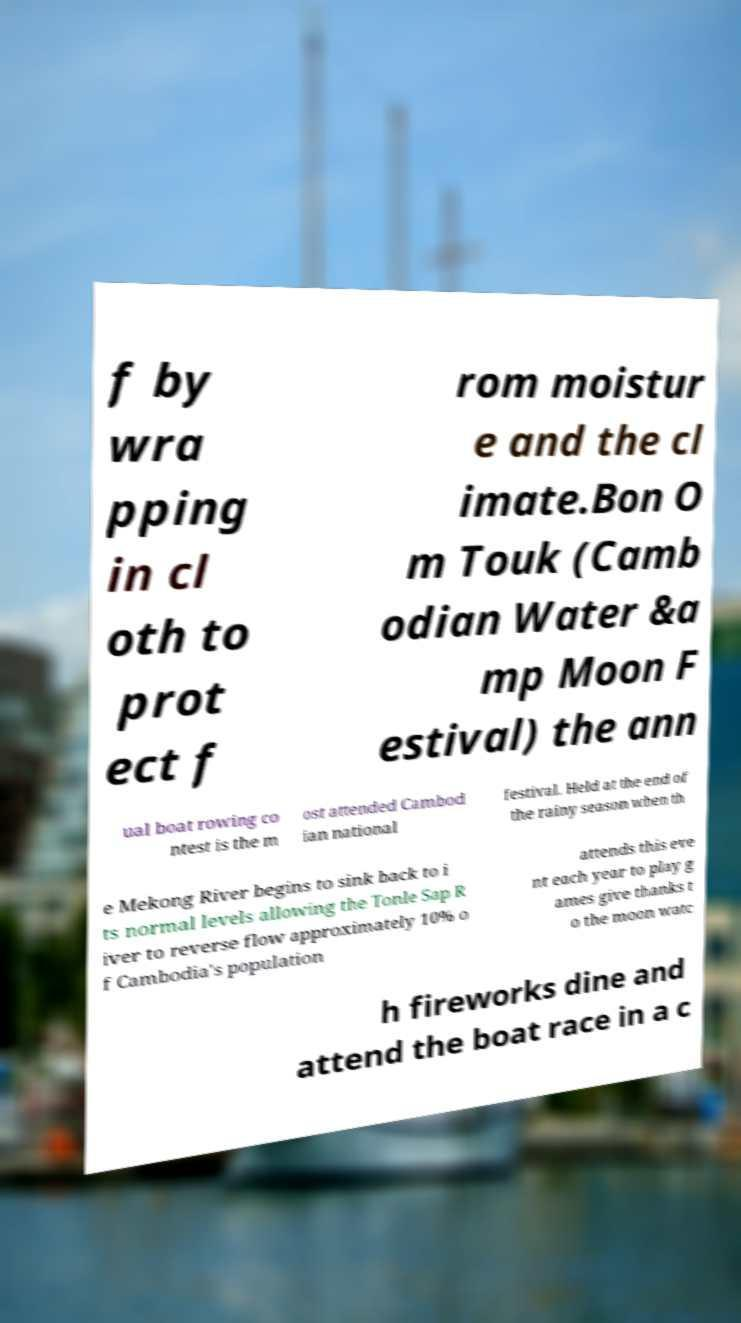Please identify and transcribe the text found in this image. f by wra pping in cl oth to prot ect f rom moistur e and the cl imate.Bon O m Touk (Camb odian Water &a mp Moon F estival) the ann ual boat rowing co ntest is the m ost attended Cambod ian national festival. Held at the end of the rainy season when th e Mekong River begins to sink back to i ts normal levels allowing the Tonle Sap R iver to reverse flow approximately 10% o f Cambodia's population attends this eve nt each year to play g ames give thanks t o the moon watc h fireworks dine and attend the boat race in a c 